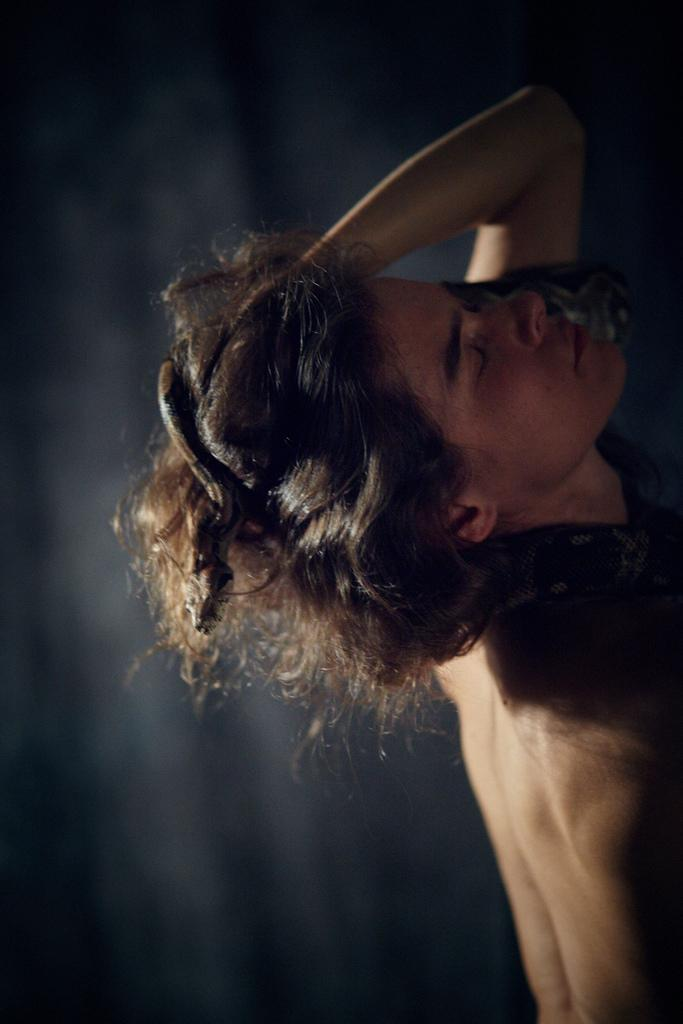What is the main subject of the image? There is a person in the image. What other living creature is present in the image? There is a snake in the image. Can you describe the background of the image? The background of the image is blurry. What type of wealth is the person displaying on the stage in the image? There is no stage present in the image, and the person's wealth is not visible or mentioned. How does the person's memory affect their interaction with the snake in the image? There is no indication of the person's memory or its impact on their interaction with the snake in the image. 